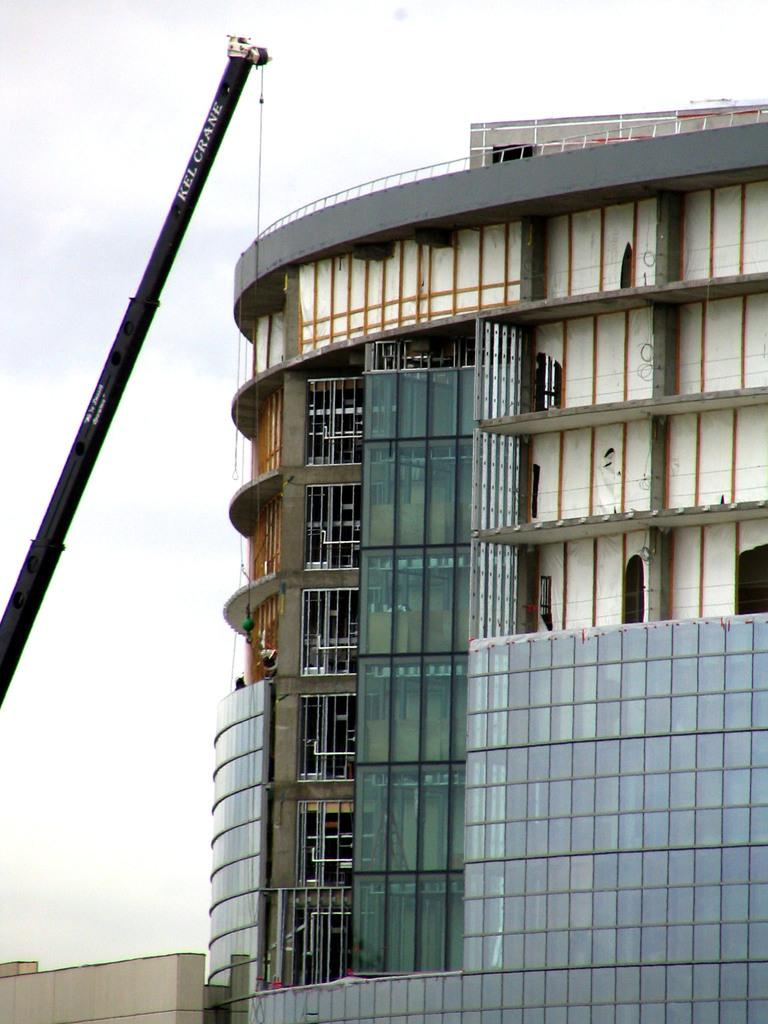What type of structure is visible in the image? There is a building in the image. What is located on the left side of the image? There is a crane on the left side of the image. What is visible at the top of the image? The sky is visible at the top of the image. What type of map can be seen on the building in the image? There is no map visible on the building in the image. How does the crane smash the building in the image? The crane does not smash the building in the image; it is stationary on the left side. 